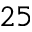Convert formula to latex. <formula><loc_0><loc_0><loc_500><loc_500>^ { 2 5 }</formula> 